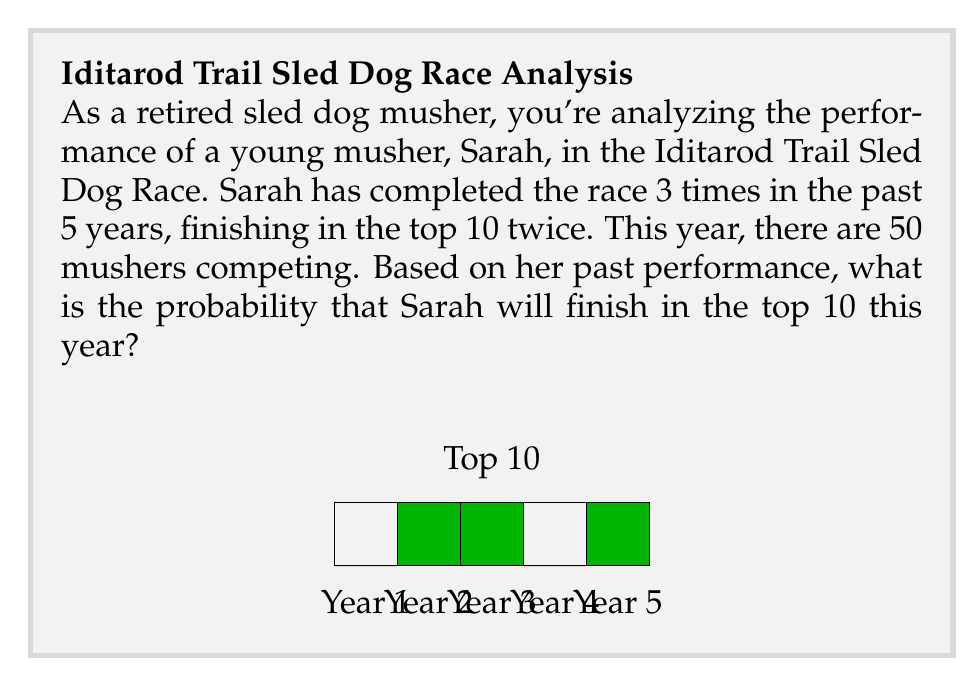Could you help me with this problem? Let's approach this step-by-step using the given information:

1) First, we need to calculate the probability of Sarah finishing in the top 10 based on her past performance.

2) Sarah has competed in the race 3 times out of the last 5 years:
   $$\text{Participation rate} = \frac{3}{5} = 0.6$$

3) Out of those 3 participations, she finished in the top 10 twice:
   $$\text{Success rate} = \frac{2}{3} \approx 0.667$$

4) Now, we need to combine these probabilities. The probability of Sarah participating and finishing in the top 10 is:
   $$P(\text{Top 10}) = P(\text{Participate}) \times P(\text{Top 10 | Participate})$$
   $$P(\text{Top 10}) = 0.6 \times 0.667 = 0.4$$

5) However, this probability assumes that all participants have an equal chance of finishing in the top 10. In reality, Sarah's past performance suggests she has a higher chance than average.

6) To account for this, we can use Bayes' theorem:

   $$P(A|B) = \frac{P(B|A) \times P(A)}{P(B)}$$

   Where:
   A = Sarah finishes in the top 10
   B = Sarah's past performance

7) We know:
   $P(B|A) = 0.667$ (probability of Sarah's past performance given she finishes in the top 10)
   $P(A) = \frac{10}{50} = 0.2$ (probability of any musher finishing in the top 10)
   $P(B) = 0.4$ (probability of Sarah's past performance)

8) Plugging these values into Bayes' theorem:

   $$P(A|B) = \frac{0.667 \times 0.2}{0.4} = 0.3335$$

Therefore, based on Sarah's past performance, the probability of her finishing in the top 10 this year is approximately 0.3335 or 33.35%.
Answer: $0.3335$ or $33.35\%$ 